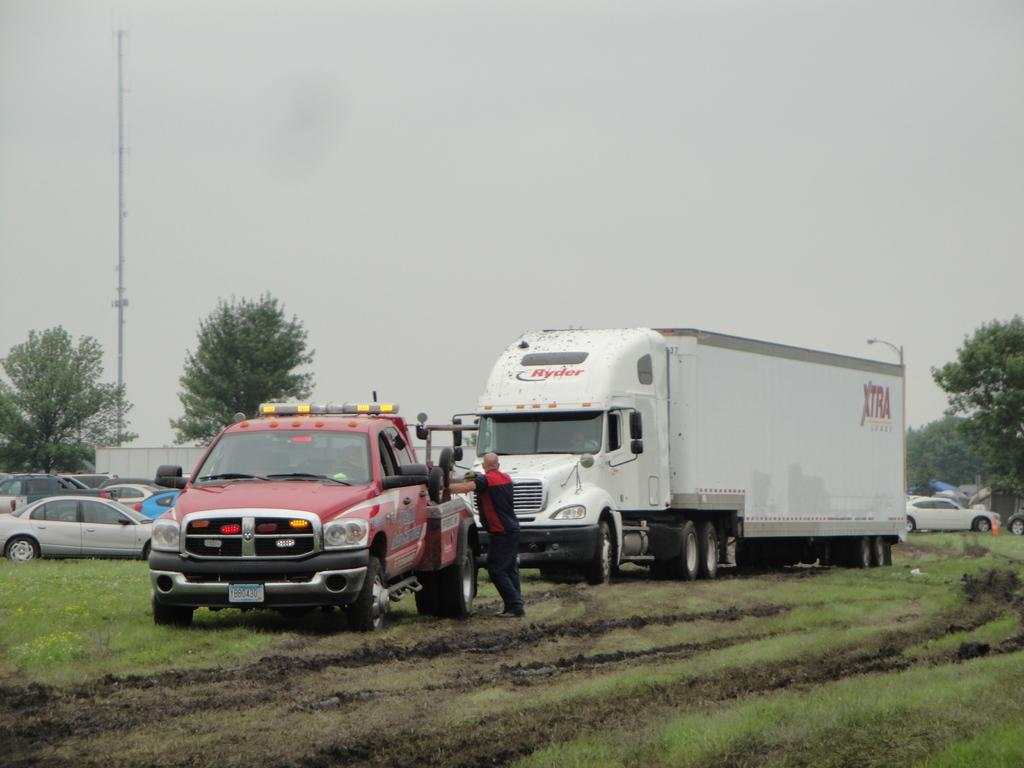What is the main subject of the image? There is a person standing in the image. What else can be seen in the image besides the person? There are vehicles visible in the image, along with grass, a pole, trees, and the sky in the background. What type of throne can be seen in the image? There is no throne present in the image. Can you hear the voice of the person in the image? The image is a visual representation, so there is no audio or voice present. 